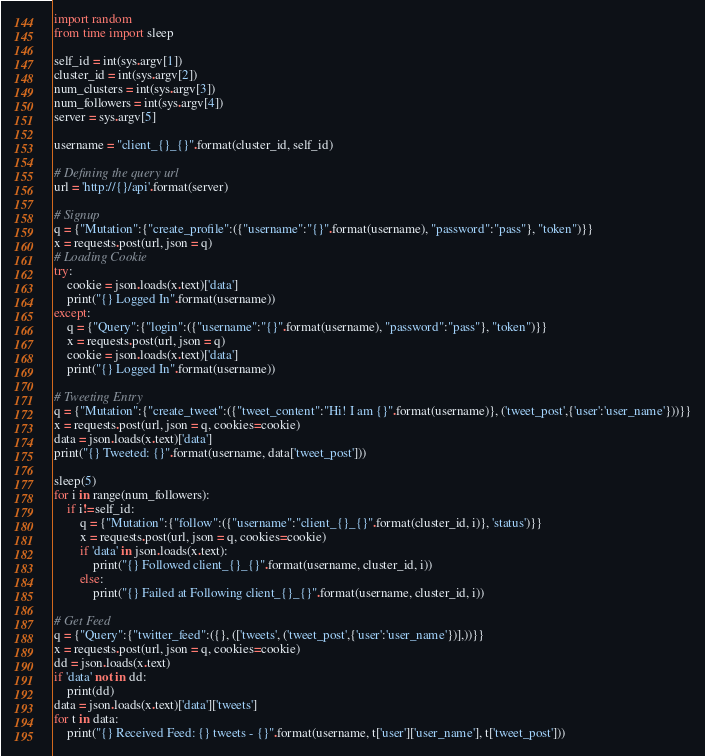Convert code to text. <code><loc_0><loc_0><loc_500><loc_500><_Python_>import random
from time import sleep

self_id = int(sys.argv[1])
cluster_id = int(sys.argv[2])
num_clusters = int(sys.argv[3])
num_followers = int(sys.argv[4])
server = sys.argv[5]

username = "client_{}_{}".format(cluster_id, self_id)

# Defining the query url
url = 'http://{}/api'.format(server)

# Signup
q = {"Mutation":{"create_profile":({"username":"{}".format(username), "password":"pass"}, "token")}}
x = requests.post(url, json = q)
# Loading Cookie
try:
	cookie = json.loads(x.text)['data']
	print("{} Logged In".format(username))
except:
	q = {"Query":{"login":({"username":"{}".format(username), "password":"pass"}, "token")}}
	x = requests.post(url, json = q)
	cookie = json.loads(x.text)['data']
	print("{} Logged In".format(username))

# Tweeting Entry
q = {"Mutation":{"create_tweet":({"tweet_content":"Hi! I am {}".format(username)}, ('tweet_post',{'user':'user_name'}))}}
x = requests.post(url, json = q, cookies=cookie)
data = json.loads(x.text)['data']
print("{} Tweeted: {}".format(username, data['tweet_post']))

sleep(5)
for i in range(num_followers):
	if i!=self_id:
		q = {"Mutation":{"follow":({"username":"client_{}_{}".format(cluster_id, i)}, 'status')}}
		x = requests.post(url, json = q, cookies=cookie)
		if 'data' in json.loads(x.text):
			print("{} Followed client_{}_{}".format(username, cluster_id, i))
		else:
			print("{} Failed at Following client_{}_{}".format(username, cluster_id, i))

# Get Feed
q = {"Query":{"twitter_feed":({}, (['tweets', ('tweet_post',{'user':'user_name'})],))}}
x = requests.post(url, json = q, cookies=cookie)
dd = json.loads(x.text)
if 'data' not in dd:
	print(dd)
data = json.loads(x.text)['data']['tweets']
for t in data:
	print("{} Received Feed: {} tweets - {}".format(username, t['user']['user_name'], t['tweet_post']))</code> 